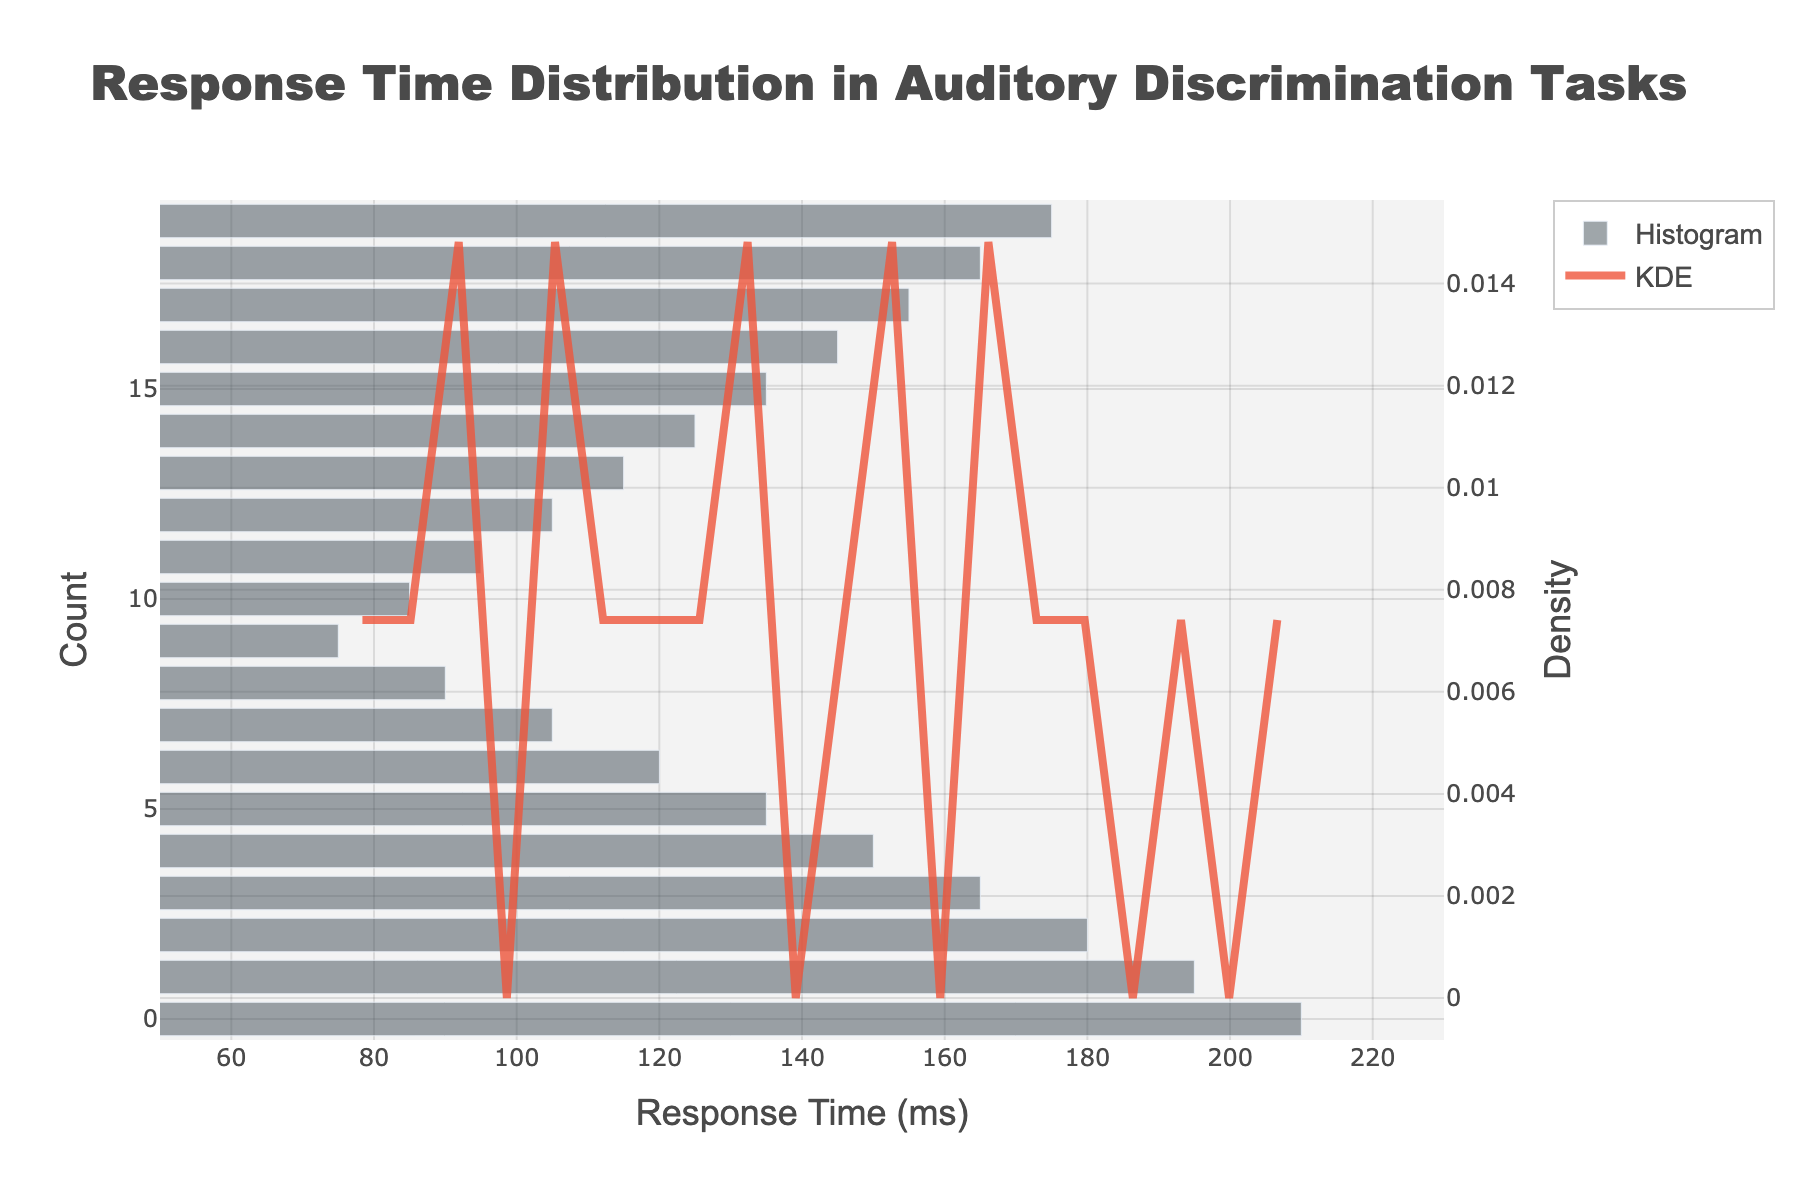What is the title of the figure? The title is typically found at the top of the figure. In this case, it is displayed prominently in a larger font size.
Answer: Response Time Distribution in Auditory Discrimination Tasks What is the x-axis title? The x-axis title describes what the x-axis represents, typically located at the bottom of the x-axis. Here, it mentions "Response Time (ms)".
Answer: Response Time (ms) What color is the KDE curve? By observing the color of the line representing the KDE curve in the figure, we can see that it is a shade of red.
Answer: Red What is the range of response times displayed on the x-axis? The x-axis range is visible by looking at the minimum and maximum values along the x-axis. Here, it ranges from 50 to 230 ms.
Answer: 50 to 230 ms At which response time does the peak of the KDE curve occur? To find the peak of the KDE curve, look for the highest point of the red line on the plot. This corresponds to the response time value directly below it on the x-axis.
Answer: Approximately 125 ms How many bins are there in the histogram? From the histogram's visual representation, we can count the individual bars to determine the number of bins.
Answer: 20 What is the approximate density value at the peak of the KDE curve? By identifying the highest point on the KDE curve and looking at the corresponding value on the secondary y-axis, we can see the density value.
Answer: Approximately 0.02 Between which two response times does the highest bar in the histogram occur? By inspecting the histogram portion of the figure, we can identify the highest bar and note the range of response times it covers.
Answer: Approximately 120 to 130 ms How would you describe the distribution shape indicated by the KDE curve? Observing the overall pattern of the KDE curve helps us identify its shape. The curve resembles a typical bell shape, indicating a normal-like distribution.
Answer: Bell-shaped Which response time range shows the lowest density according to the KDE curve? Observing the KDE curve, the lowest density is where the line is closest to the baseline. This occurs at the extreme ends of the response time range.
Answer: Around 50 ms and 230 ms 